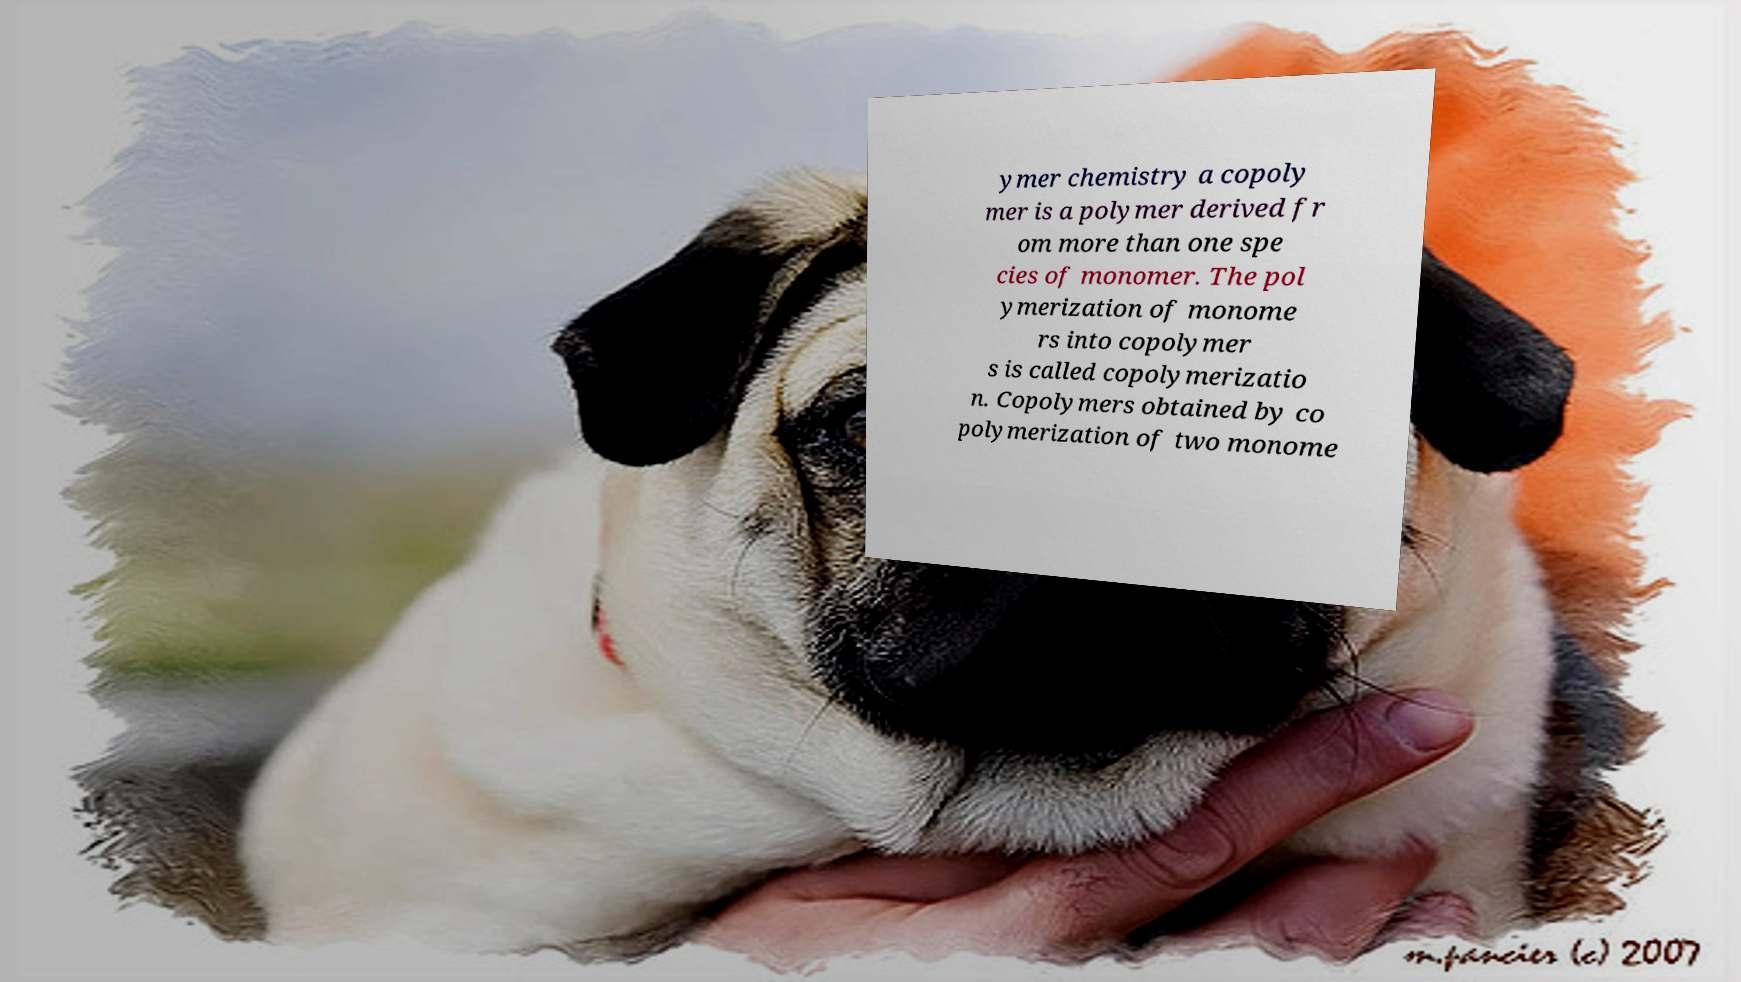Can you accurately transcribe the text from the provided image for me? ymer chemistry a copoly mer is a polymer derived fr om more than one spe cies of monomer. The pol ymerization of monome rs into copolymer s is called copolymerizatio n. Copolymers obtained by co polymerization of two monome 